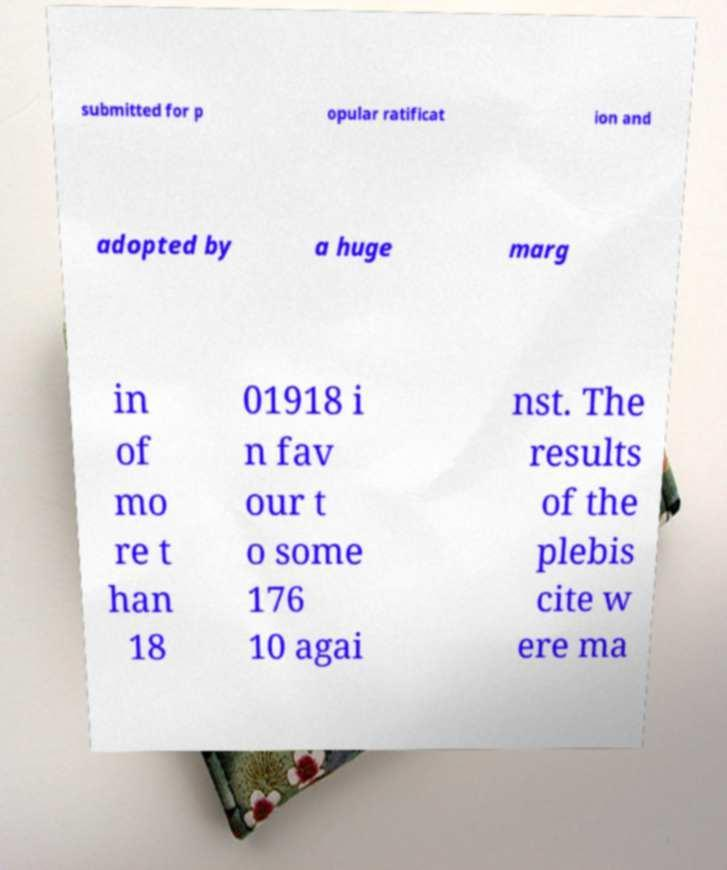Can you accurately transcribe the text from the provided image for me? submitted for p opular ratificat ion and adopted by a huge marg in of mo re t han 18 01918 i n fav our t o some 176 10 agai nst. The results of the plebis cite w ere ma 